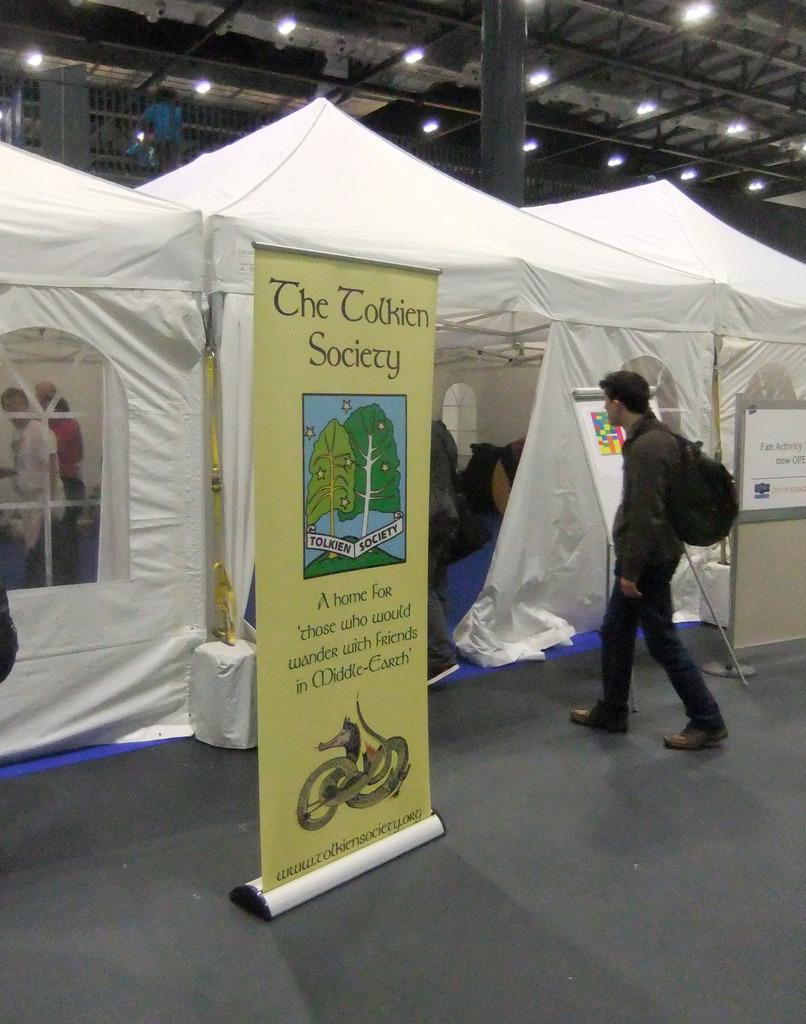What is located in the middle of the image? There is a banner in the middle of the image. What is the man on the right side of the image doing? The man is walking on the right side of the image. What type of temporary shelter can be seen in the image? There appears to be a tent in the image. What is visible at the top of the image? Lights are visible at the top of the image. How many people are playing on the board in the image? There is no board or people playing on it present in the image. What type of spot is visible on the man's shirt in the image? There is no spot visible on the man's shirt in the image. 